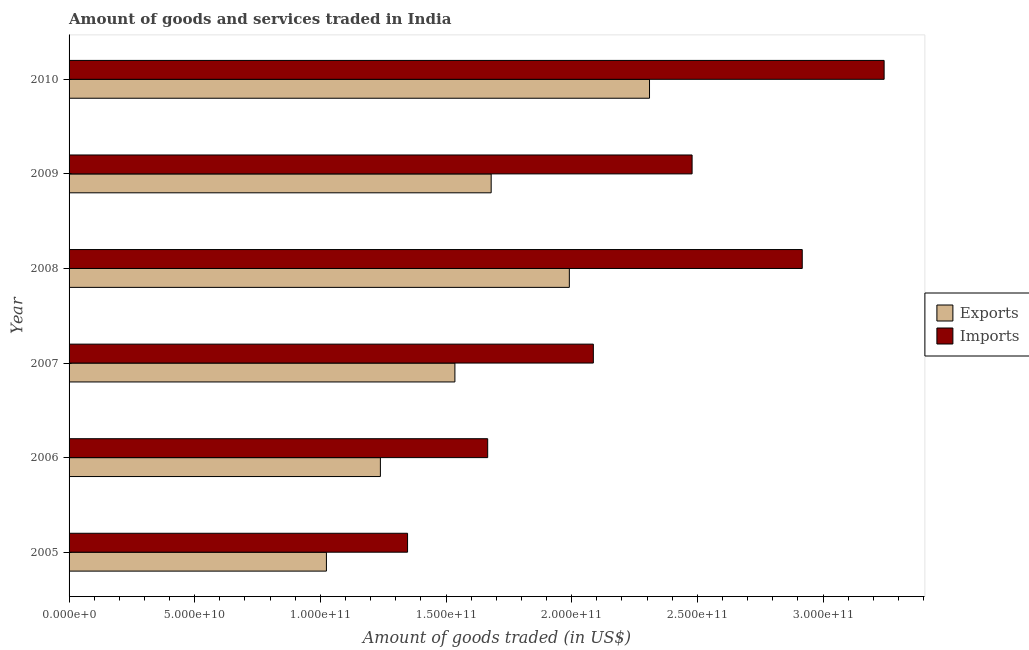How many different coloured bars are there?
Give a very brief answer. 2. Are the number of bars on each tick of the Y-axis equal?
Your answer should be very brief. Yes. What is the label of the 6th group of bars from the top?
Make the answer very short. 2005. In how many cases, is the number of bars for a given year not equal to the number of legend labels?
Keep it short and to the point. 0. What is the amount of goods imported in 2009?
Offer a terse response. 2.48e+11. Across all years, what is the maximum amount of goods imported?
Your response must be concise. 3.24e+11. Across all years, what is the minimum amount of goods imported?
Keep it short and to the point. 1.35e+11. In which year was the amount of goods imported minimum?
Your answer should be very brief. 2005. What is the total amount of goods exported in the graph?
Offer a very short reply. 9.78e+11. What is the difference between the amount of goods imported in 2006 and that in 2008?
Your answer should be very brief. -1.25e+11. What is the difference between the amount of goods imported in 2007 and the amount of goods exported in 2005?
Give a very brief answer. 1.06e+11. What is the average amount of goods imported per year?
Provide a succinct answer. 2.29e+11. In the year 2010, what is the difference between the amount of goods exported and amount of goods imported?
Keep it short and to the point. -9.34e+1. What is the ratio of the amount of goods exported in 2006 to that in 2009?
Your response must be concise. 0.74. Is the amount of goods imported in 2007 less than that in 2008?
Provide a succinct answer. Yes. Is the difference between the amount of goods exported in 2009 and 2010 greater than the difference between the amount of goods imported in 2009 and 2010?
Your answer should be very brief. Yes. What is the difference between the highest and the second highest amount of goods exported?
Ensure brevity in your answer.  3.19e+1. What is the difference between the highest and the lowest amount of goods imported?
Offer a very short reply. 1.90e+11. In how many years, is the amount of goods imported greater than the average amount of goods imported taken over all years?
Make the answer very short. 3. Is the sum of the amount of goods exported in 2008 and 2009 greater than the maximum amount of goods imported across all years?
Your answer should be very brief. Yes. What does the 2nd bar from the top in 2009 represents?
Your response must be concise. Exports. What does the 2nd bar from the bottom in 2009 represents?
Your answer should be very brief. Imports. How many bars are there?
Give a very brief answer. 12. How many years are there in the graph?
Offer a terse response. 6. Does the graph contain any zero values?
Your answer should be very brief. No. Does the graph contain grids?
Your answer should be compact. No. Where does the legend appear in the graph?
Keep it short and to the point. Center right. How are the legend labels stacked?
Ensure brevity in your answer.  Vertical. What is the title of the graph?
Your answer should be very brief. Amount of goods and services traded in India. Does "Female" appear as one of the legend labels in the graph?
Your answer should be very brief. No. What is the label or title of the X-axis?
Keep it short and to the point. Amount of goods traded (in US$). What is the Amount of goods traded (in US$) of Exports in 2005?
Your response must be concise. 1.02e+11. What is the Amount of goods traded (in US$) of Imports in 2005?
Your response must be concise. 1.35e+11. What is the Amount of goods traded (in US$) in Exports in 2006?
Give a very brief answer. 1.24e+11. What is the Amount of goods traded (in US$) of Imports in 2006?
Offer a very short reply. 1.67e+11. What is the Amount of goods traded (in US$) of Exports in 2007?
Offer a very short reply. 1.54e+11. What is the Amount of goods traded (in US$) of Imports in 2007?
Provide a succinct answer. 2.09e+11. What is the Amount of goods traded (in US$) of Exports in 2008?
Provide a succinct answer. 1.99e+11. What is the Amount of goods traded (in US$) in Imports in 2008?
Ensure brevity in your answer.  2.92e+11. What is the Amount of goods traded (in US$) of Exports in 2009?
Offer a terse response. 1.68e+11. What is the Amount of goods traded (in US$) of Imports in 2009?
Your response must be concise. 2.48e+11. What is the Amount of goods traded (in US$) in Exports in 2010?
Offer a terse response. 2.31e+11. What is the Amount of goods traded (in US$) of Imports in 2010?
Provide a short and direct response. 3.24e+11. Across all years, what is the maximum Amount of goods traded (in US$) in Exports?
Offer a very short reply. 2.31e+11. Across all years, what is the maximum Amount of goods traded (in US$) in Imports?
Ensure brevity in your answer.  3.24e+11. Across all years, what is the minimum Amount of goods traded (in US$) in Exports?
Your answer should be compact. 1.02e+11. Across all years, what is the minimum Amount of goods traded (in US$) in Imports?
Offer a terse response. 1.35e+11. What is the total Amount of goods traded (in US$) in Exports in the graph?
Offer a very short reply. 9.78e+11. What is the total Amount of goods traded (in US$) of Imports in the graph?
Your answer should be compact. 1.37e+12. What is the difference between the Amount of goods traded (in US$) of Exports in 2005 and that in 2006?
Provide a short and direct response. -2.15e+1. What is the difference between the Amount of goods traded (in US$) of Imports in 2005 and that in 2006?
Provide a short and direct response. -3.19e+1. What is the difference between the Amount of goods traded (in US$) of Exports in 2005 and that in 2007?
Your response must be concise. -5.11e+1. What is the difference between the Amount of goods traded (in US$) in Imports in 2005 and that in 2007?
Provide a succinct answer. -7.39e+1. What is the difference between the Amount of goods traded (in US$) of Exports in 2005 and that in 2008?
Offer a very short reply. -9.67e+1. What is the difference between the Amount of goods traded (in US$) in Imports in 2005 and that in 2008?
Ensure brevity in your answer.  -1.57e+11. What is the difference between the Amount of goods traded (in US$) in Exports in 2005 and that in 2009?
Your response must be concise. -6.56e+1. What is the difference between the Amount of goods traded (in US$) in Imports in 2005 and that in 2009?
Ensure brevity in your answer.  -1.13e+11. What is the difference between the Amount of goods traded (in US$) of Exports in 2005 and that in 2010?
Offer a terse response. -1.29e+11. What is the difference between the Amount of goods traded (in US$) in Imports in 2005 and that in 2010?
Provide a short and direct response. -1.90e+11. What is the difference between the Amount of goods traded (in US$) in Exports in 2006 and that in 2007?
Offer a terse response. -2.97e+1. What is the difference between the Amount of goods traded (in US$) in Imports in 2006 and that in 2007?
Make the answer very short. -4.20e+1. What is the difference between the Amount of goods traded (in US$) in Exports in 2006 and that in 2008?
Keep it short and to the point. -7.52e+1. What is the difference between the Amount of goods traded (in US$) in Imports in 2006 and that in 2008?
Make the answer very short. -1.25e+11. What is the difference between the Amount of goods traded (in US$) in Exports in 2006 and that in 2009?
Provide a succinct answer. -4.41e+1. What is the difference between the Amount of goods traded (in US$) in Imports in 2006 and that in 2009?
Provide a short and direct response. -8.13e+1. What is the difference between the Amount of goods traded (in US$) in Exports in 2006 and that in 2010?
Make the answer very short. -1.07e+11. What is the difference between the Amount of goods traded (in US$) in Imports in 2006 and that in 2010?
Provide a succinct answer. -1.58e+11. What is the difference between the Amount of goods traded (in US$) in Exports in 2007 and that in 2008?
Offer a terse response. -4.55e+1. What is the difference between the Amount of goods traded (in US$) of Imports in 2007 and that in 2008?
Your response must be concise. -8.31e+1. What is the difference between the Amount of goods traded (in US$) in Exports in 2007 and that in 2009?
Your response must be concise. -1.44e+1. What is the difference between the Amount of goods traded (in US$) of Imports in 2007 and that in 2009?
Keep it short and to the point. -3.93e+1. What is the difference between the Amount of goods traded (in US$) of Exports in 2007 and that in 2010?
Make the answer very short. -7.74e+1. What is the difference between the Amount of goods traded (in US$) in Imports in 2007 and that in 2010?
Give a very brief answer. -1.16e+11. What is the difference between the Amount of goods traded (in US$) of Exports in 2008 and that in 2009?
Offer a terse response. 3.11e+1. What is the difference between the Amount of goods traded (in US$) in Imports in 2008 and that in 2009?
Make the answer very short. 4.38e+1. What is the difference between the Amount of goods traded (in US$) in Exports in 2008 and that in 2010?
Make the answer very short. -3.19e+1. What is the difference between the Amount of goods traded (in US$) of Imports in 2008 and that in 2010?
Ensure brevity in your answer.  -3.26e+1. What is the difference between the Amount of goods traded (in US$) in Exports in 2009 and that in 2010?
Keep it short and to the point. -6.30e+1. What is the difference between the Amount of goods traded (in US$) of Imports in 2009 and that in 2010?
Provide a short and direct response. -7.64e+1. What is the difference between the Amount of goods traded (in US$) in Exports in 2005 and the Amount of goods traded (in US$) in Imports in 2006?
Your answer should be compact. -6.42e+1. What is the difference between the Amount of goods traded (in US$) in Exports in 2005 and the Amount of goods traded (in US$) in Imports in 2007?
Your answer should be compact. -1.06e+11. What is the difference between the Amount of goods traded (in US$) in Exports in 2005 and the Amount of goods traded (in US$) in Imports in 2008?
Keep it short and to the point. -1.89e+11. What is the difference between the Amount of goods traded (in US$) of Exports in 2005 and the Amount of goods traded (in US$) of Imports in 2009?
Offer a terse response. -1.46e+11. What is the difference between the Amount of goods traded (in US$) in Exports in 2005 and the Amount of goods traded (in US$) in Imports in 2010?
Ensure brevity in your answer.  -2.22e+11. What is the difference between the Amount of goods traded (in US$) in Exports in 2006 and the Amount of goods traded (in US$) in Imports in 2007?
Offer a very short reply. -8.47e+1. What is the difference between the Amount of goods traded (in US$) of Exports in 2006 and the Amount of goods traded (in US$) of Imports in 2008?
Offer a terse response. -1.68e+11. What is the difference between the Amount of goods traded (in US$) in Exports in 2006 and the Amount of goods traded (in US$) in Imports in 2009?
Your answer should be very brief. -1.24e+11. What is the difference between the Amount of goods traded (in US$) in Exports in 2006 and the Amount of goods traded (in US$) in Imports in 2010?
Make the answer very short. -2.00e+11. What is the difference between the Amount of goods traded (in US$) in Exports in 2007 and the Amount of goods traded (in US$) in Imports in 2008?
Your answer should be very brief. -1.38e+11. What is the difference between the Amount of goods traded (in US$) in Exports in 2007 and the Amount of goods traded (in US$) in Imports in 2009?
Make the answer very short. -9.44e+1. What is the difference between the Amount of goods traded (in US$) of Exports in 2007 and the Amount of goods traded (in US$) of Imports in 2010?
Your answer should be compact. -1.71e+11. What is the difference between the Amount of goods traded (in US$) of Exports in 2008 and the Amount of goods traded (in US$) of Imports in 2009?
Keep it short and to the point. -4.88e+1. What is the difference between the Amount of goods traded (in US$) in Exports in 2008 and the Amount of goods traded (in US$) in Imports in 2010?
Your answer should be compact. -1.25e+11. What is the difference between the Amount of goods traded (in US$) of Exports in 2009 and the Amount of goods traded (in US$) of Imports in 2010?
Offer a very short reply. -1.56e+11. What is the average Amount of goods traded (in US$) of Exports per year?
Your response must be concise. 1.63e+11. What is the average Amount of goods traded (in US$) in Imports per year?
Your answer should be compact. 2.29e+11. In the year 2005, what is the difference between the Amount of goods traded (in US$) of Exports and Amount of goods traded (in US$) of Imports?
Make the answer very short. -3.23e+1. In the year 2006, what is the difference between the Amount of goods traded (in US$) in Exports and Amount of goods traded (in US$) in Imports?
Keep it short and to the point. -4.27e+1. In the year 2007, what is the difference between the Amount of goods traded (in US$) in Exports and Amount of goods traded (in US$) in Imports?
Provide a short and direct response. -5.51e+1. In the year 2008, what is the difference between the Amount of goods traded (in US$) in Exports and Amount of goods traded (in US$) in Imports?
Ensure brevity in your answer.  -9.27e+1. In the year 2009, what is the difference between the Amount of goods traded (in US$) of Exports and Amount of goods traded (in US$) of Imports?
Provide a succinct answer. -8.00e+1. In the year 2010, what is the difference between the Amount of goods traded (in US$) in Exports and Amount of goods traded (in US$) in Imports?
Your response must be concise. -9.34e+1. What is the ratio of the Amount of goods traded (in US$) of Exports in 2005 to that in 2006?
Keep it short and to the point. 0.83. What is the ratio of the Amount of goods traded (in US$) of Imports in 2005 to that in 2006?
Provide a succinct answer. 0.81. What is the ratio of the Amount of goods traded (in US$) of Exports in 2005 to that in 2007?
Your answer should be compact. 0.67. What is the ratio of the Amount of goods traded (in US$) in Imports in 2005 to that in 2007?
Your answer should be very brief. 0.65. What is the ratio of the Amount of goods traded (in US$) in Exports in 2005 to that in 2008?
Offer a very short reply. 0.51. What is the ratio of the Amount of goods traded (in US$) of Imports in 2005 to that in 2008?
Ensure brevity in your answer.  0.46. What is the ratio of the Amount of goods traded (in US$) in Exports in 2005 to that in 2009?
Your answer should be compact. 0.61. What is the ratio of the Amount of goods traded (in US$) in Imports in 2005 to that in 2009?
Your response must be concise. 0.54. What is the ratio of the Amount of goods traded (in US$) of Exports in 2005 to that in 2010?
Your answer should be very brief. 0.44. What is the ratio of the Amount of goods traded (in US$) of Imports in 2005 to that in 2010?
Make the answer very short. 0.42. What is the ratio of the Amount of goods traded (in US$) of Exports in 2006 to that in 2007?
Your answer should be compact. 0.81. What is the ratio of the Amount of goods traded (in US$) of Imports in 2006 to that in 2007?
Your answer should be very brief. 0.8. What is the ratio of the Amount of goods traded (in US$) of Exports in 2006 to that in 2008?
Provide a short and direct response. 0.62. What is the ratio of the Amount of goods traded (in US$) of Imports in 2006 to that in 2008?
Offer a terse response. 0.57. What is the ratio of the Amount of goods traded (in US$) in Exports in 2006 to that in 2009?
Offer a terse response. 0.74. What is the ratio of the Amount of goods traded (in US$) of Imports in 2006 to that in 2009?
Your answer should be very brief. 0.67. What is the ratio of the Amount of goods traded (in US$) of Exports in 2006 to that in 2010?
Ensure brevity in your answer.  0.54. What is the ratio of the Amount of goods traded (in US$) in Imports in 2006 to that in 2010?
Keep it short and to the point. 0.51. What is the ratio of the Amount of goods traded (in US$) in Exports in 2007 to that in 2008?
Provide a succinct answer. 0.77. What is the ratio of the Amount of goods traded (in US$) in Imports in 2007 to that in 2008?
Your answer should be compact. 0.72. What is the ratio of the Amount of goods traded (in US$) of Exports in 2007 to that in 2009?
Your answer should be very brief. 0.91. What is the ratio of the Amount of goods traded (in US$) of Imports in 2007 to that in 2009?
Your answer should be compact. 0.84. What is the ratio of the Amount of goods traded (in US$) in Exports in 2007 to that in 2010?
Ensure brevity in your answer.  0.66. What is the ratio of the Amount of goods traded (in US$) in Imports in 2007 to that in 2010?
Provide a short and direct response. 0.64. What is the ratio of the Amount of goods traded (in US$) of Exports in 2008 to that in 2009?
Make the answer very short. 1.19. What is the ratio of the Amount of goods traded (in US$) of Imports in 2008 to that in 2009?
Provide a succinct answer. 1.18. What is the ratio of the Amount of goods traded (in US$) in Exports in 2008 to that in 2010?
Your answer should be compact. 0.86. What is the ratio of the Amount of goods traded (in US$) of Imports in 2008 to that in 2010?
Your answer should be compact. 0.9. What is the ratio of the Amount of goods traded (in US$) of Exports in 2009 to that in 2010?
Make the answer very short. 0.73. What is the ratio of the Amount of goods traded (in US$) in Imports in 2009 to that in 2010?
Offer a very short reply. 0.76. What is the difference between the highest and the second highest Amount of goods traded (in US$) in Exports?
Give a very brief answer. 3.19e+1. What is the difference between the highest and the second highest Amount of goods traded (in US$) of Imports?
Make the answer very short. 3.26e+1. What is the difference between the highest and the lowest Amount of goods traded (in US$) of Exports?
Your answer should be compact. 1.29e+11. What is the difference between the highest and the lowest Amount of goods traded (in US$) of Imports?
Offer a terse response. 1.90e+11. 